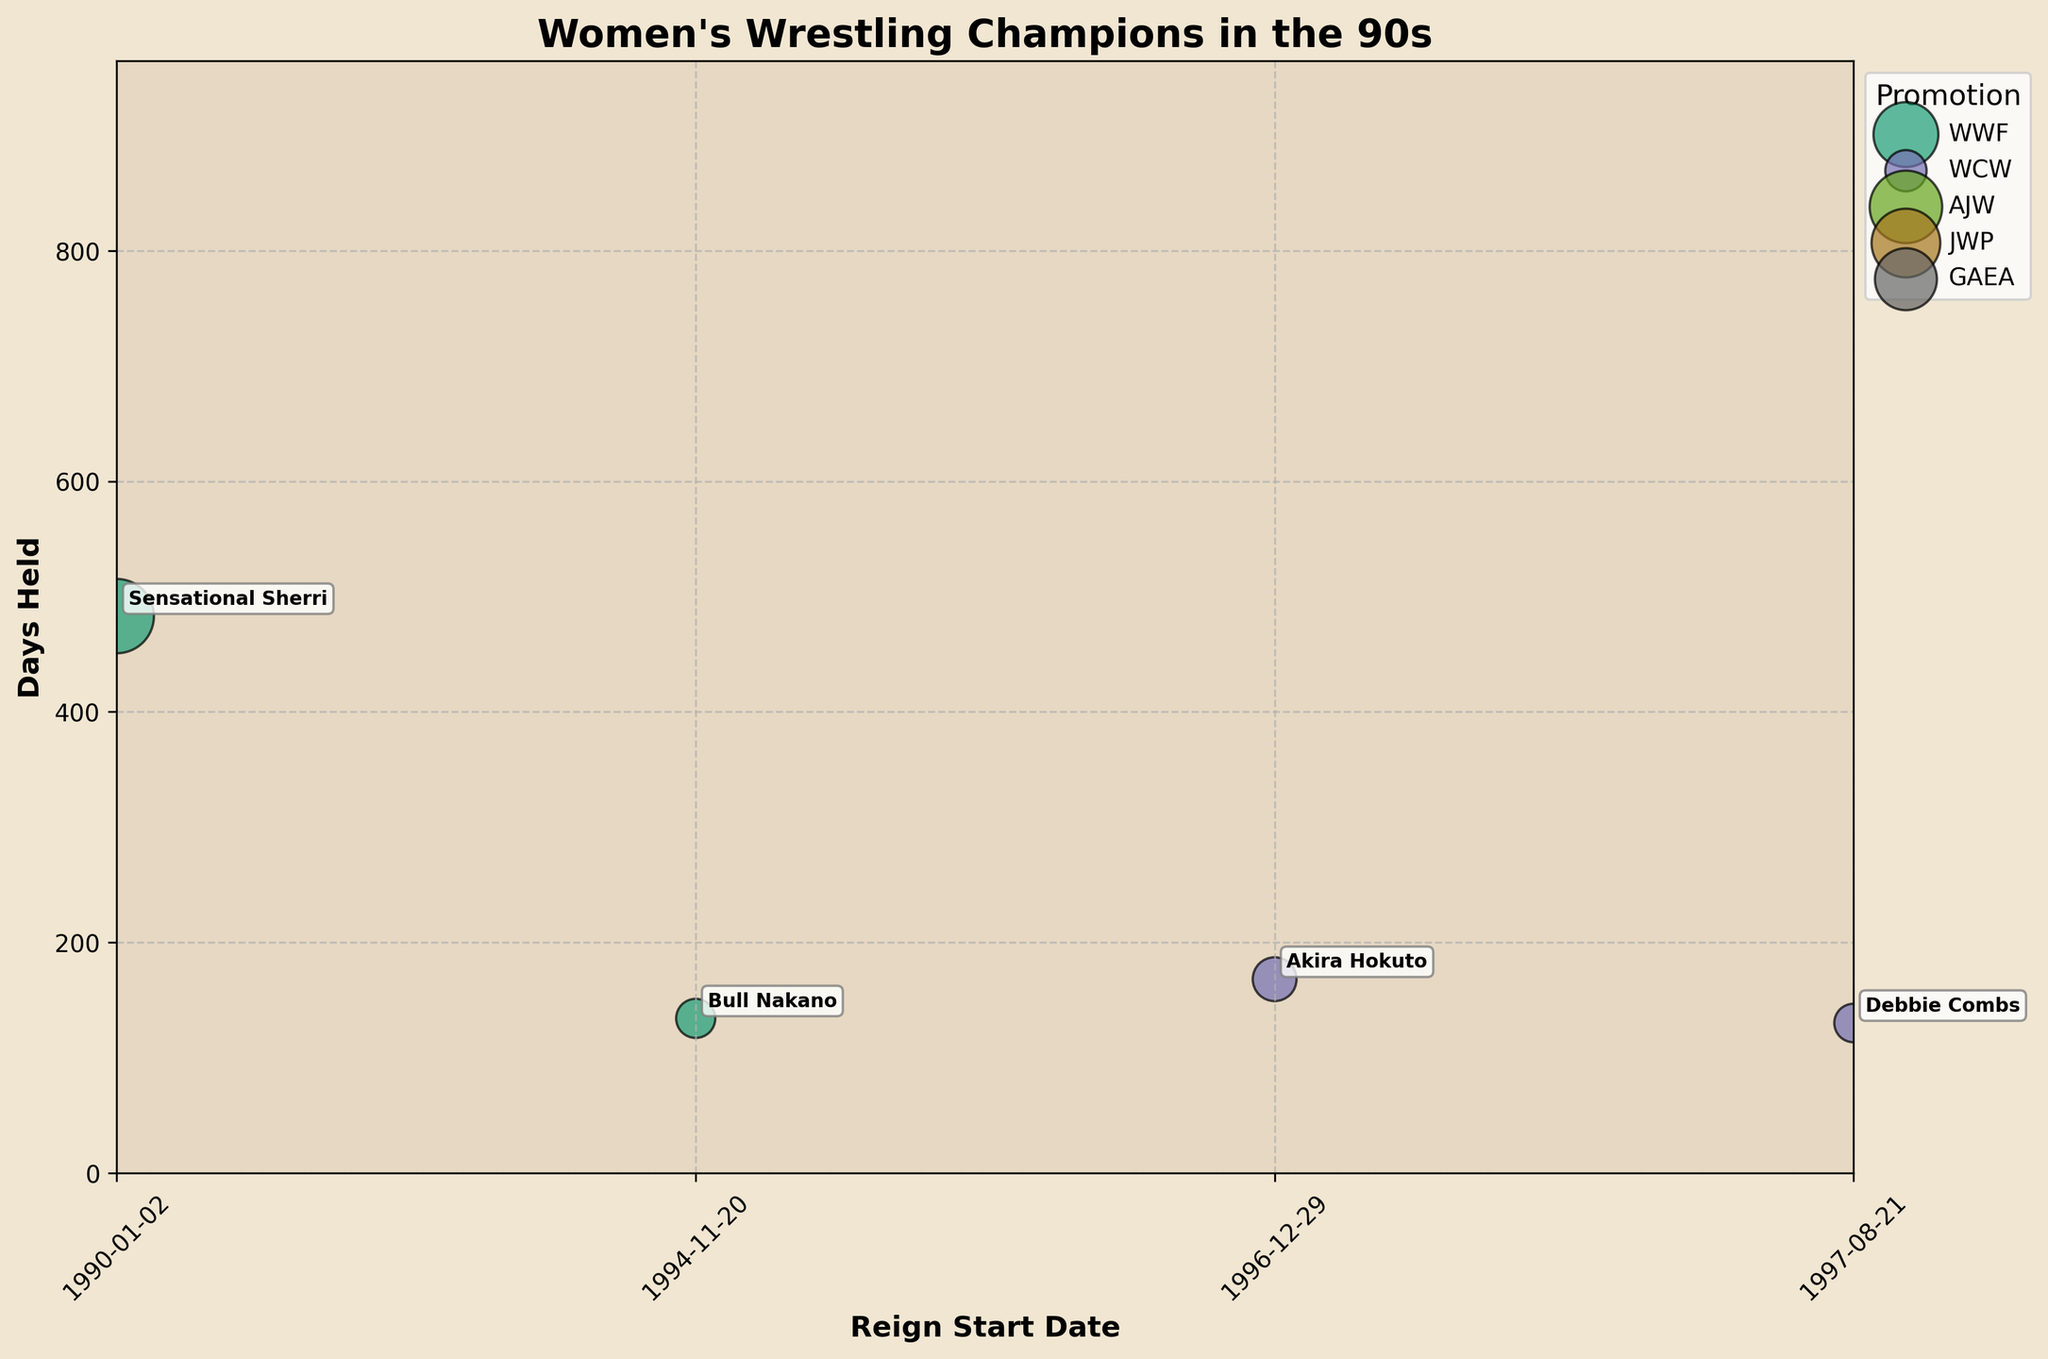What is the title of the figure? The title is prominently displayed at the top of the figure in bold font. It summarizes what the chart is about.
Answer: Women's Wrestling Champions in the 90s Which promotion has the most data points? By visually counting the number of bubbles corresponding to each promotion's legend color, you can determine which promotion has the most data points.
Answer: AJW Who has the longest title reign in WWF among the champions in the 90s? Check for the largest bubble within WWF's colored bubbles and identify the champion's name annotated next to it.
Answer: Alundra Blayze Which promotion has the champion with the longest title reign and how long was it? Check for the largest bubble in the entire chart, regardless of color, and read the associated promotion and days held.
Answer: AJW, 877 days How many promotions are represented in the chart? Count the number of different unique colors or check the legend to see how many different promotions are listed.
Answer: 4 Which champion held the title for 103 days more than Bull Nakano's second-longest reign in the 90s? Bull Nakano's second-longest reign in WWF was 134 days. Adding 103 days gives 237 days. Look for the bubble closest to 237 days and check the annotation.
Answer: Plum Mariko Who held the title for the shortest time in AJW and how long was it? Compare the smallest bubbles for AJW's color and see the annotation text next to the smallest bubble to identify the champion and check the days held.
Answer: Manami Toyota, 42 days Is there any champion who held a title in more than one promotion? If yes, who? Check if any champion's name appears in more than one promotion by comparing the annotations for each plot.
Answer: Bull Nakano Which promotion had more variability in the title reign lengths? By comparing the spread of bubble sizes vertically for each promotion, the promotion with the most vertical spread indicates higher variability.
Answer: AJW Was the title reign duration generally shorter in WWF or GAEA? Compare the general size of bubbles in WWF and GAEA. The promotion with generally smaller bubbles had shorter reigns.
Answer: WWF 